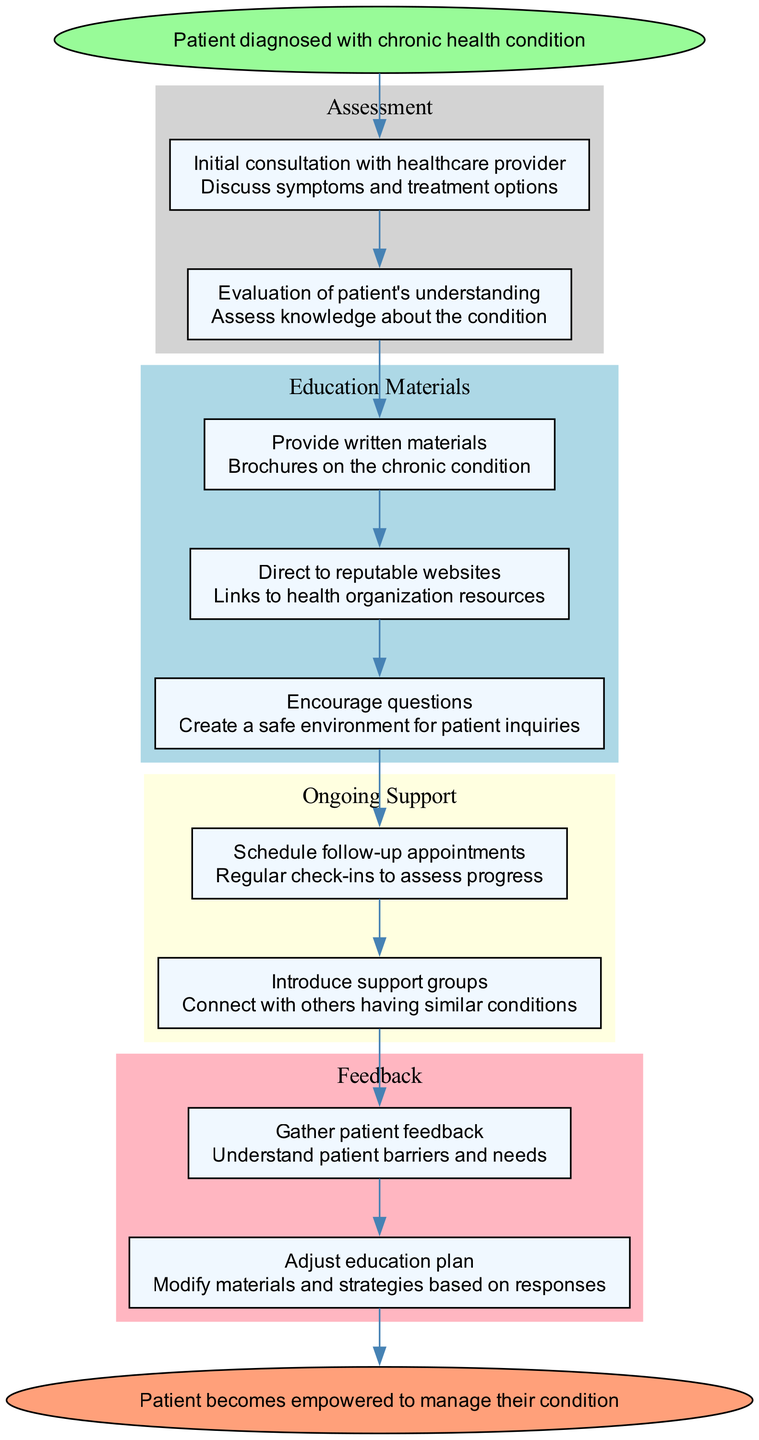What is the starting point of the patient education journey? The diagram starts with the node labeled "Patient diagnosed with chronic health condition," which indicates the initial stage of the patient education journey.
Answer: Patient diagnosed with chronic health condition How many steps are there in the Assessment phase? The Assessment phase contains two steps, as listed in the diagram: "Initial consultation with healthcare provider" and "Evaluation of patient's understanding."
Answer: 2 What type of materials are provided in the Education Materials phase? The Education Materials phase includes written materials and web resources, specifically "brochures on the chronic condition" and "links to health organization resources."
Answer: Written materials What follows after the Education Materials phase? After the Education Materials phase, the flow moves directly into the Ongoing Support phase as indicated by the arrow connecting the last step of Education Materials to the first step of Ongoing Support.
Answer: Ongoing Support How does patient feedback influence the education plan? Patient feedback is gathered to understand their barriers and needs, which informs the adjustment of the education plan by modifying materials and strategies based on responses. This shows a clear loop from feedback to adjustments.
Answer: Adjust education plan What connects the last step of the Ongoing Support to the Feedback phase? The arrow connecting the last step of the Ongoing Support phase points to the first step of the Feedback phase, indicating that ongoing support leads directly into gathering feedback from the patient about their education experience.
Answer: Feedback How many steps are there in the Feedback phase? The Feedback phase consists of two steps as indicated by the distinct nodes labeled "Gather patient feedback" and "Adjust education plan."
Answer: 2 What is the ultimate goal of the patient education journey represented in the diagram? The final point in the flow chart indicates that the "Patient becomes empowered to manage their condition," which summarizes the objective of the journey.
Answer: Patient becomes empowered to manage their condition 